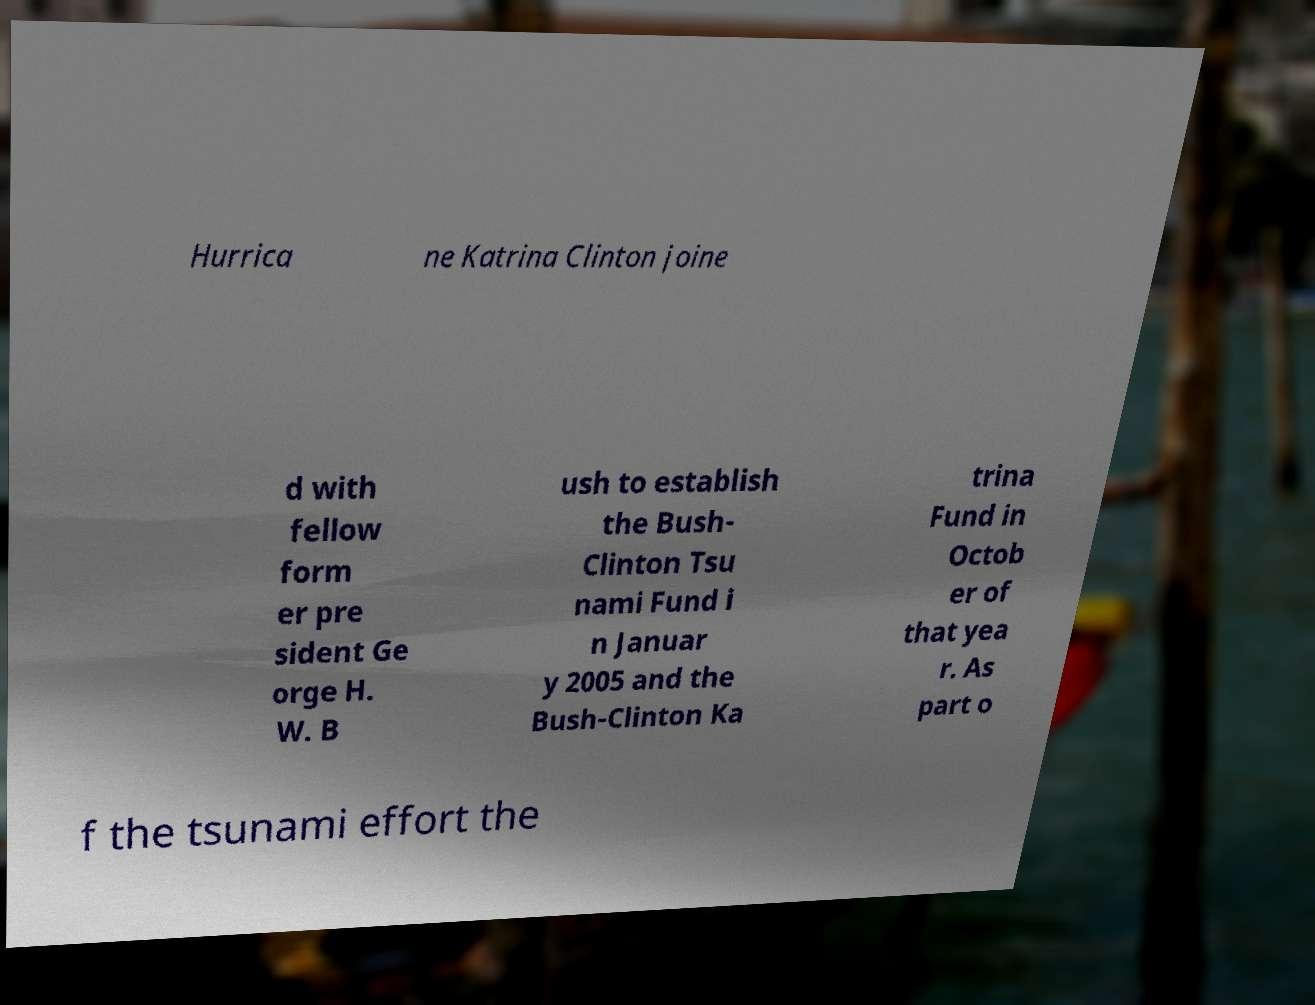I need the written content from this picture converted into text. Can you do that? Hurrica ne Katrina Clinton joine d with fellow form er pre sident Ge orge H. W. B ush to establish the Bush- Clinton Tsu nami Fund i n Januar y 2005 and the Bush-Clinton Ka trina Fund in Octob er of that yea r. As part o f the tsunami effort the 